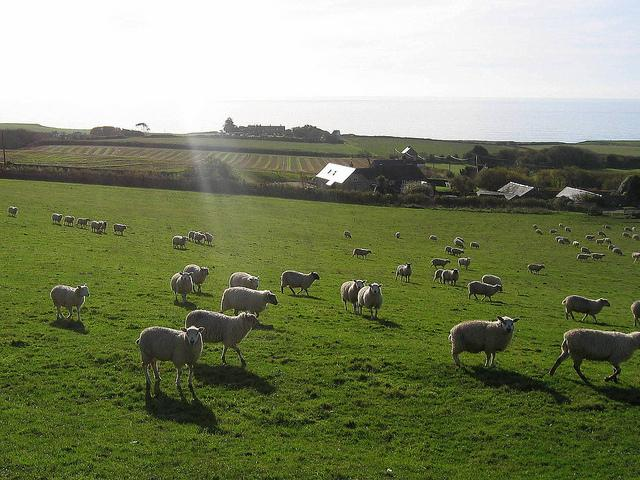What type of worker would be found here? Please explain your reasoning. farmer. Farmers are the people who herd sheep. 